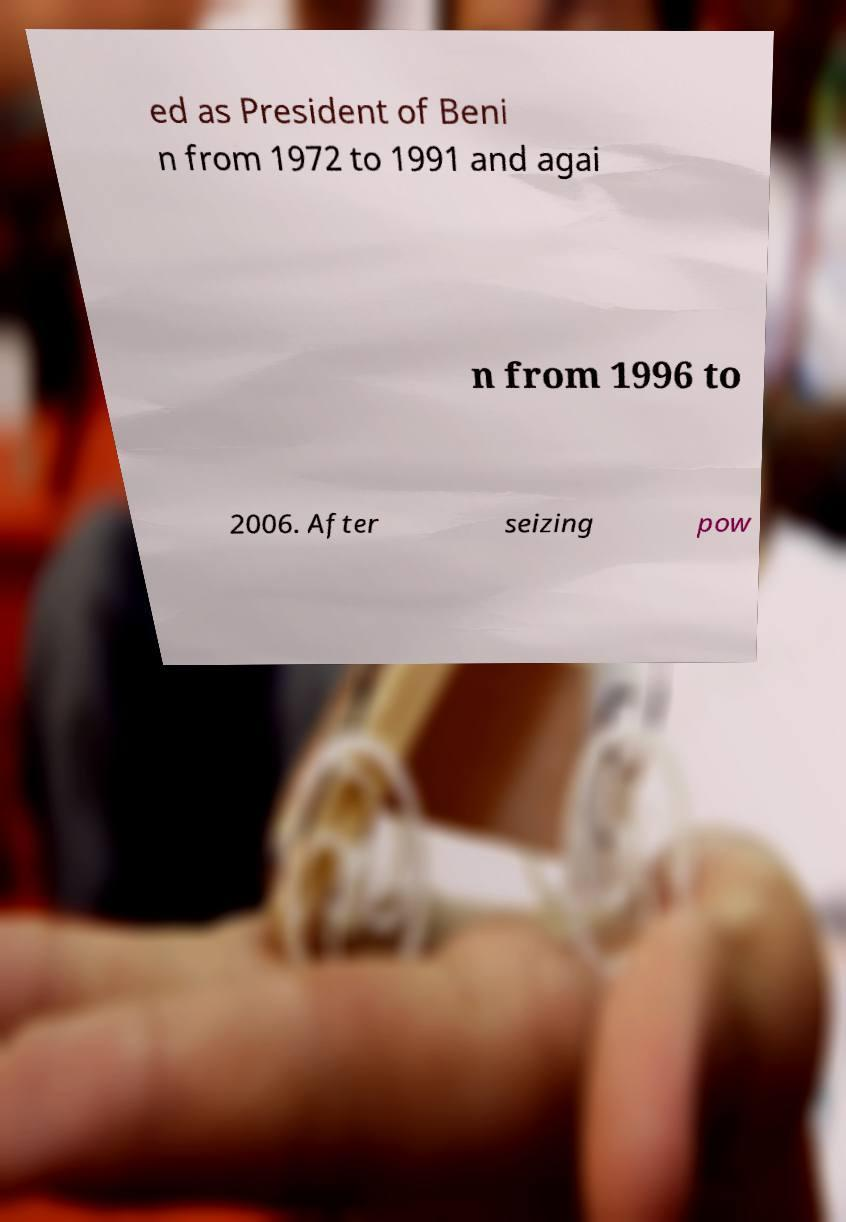What messages or text are displayed in this image? I need them in a readable, typed format. ed as President of Beni n from 1972 to 1991 and agai n from 1996 to 2006. After seizing pow 